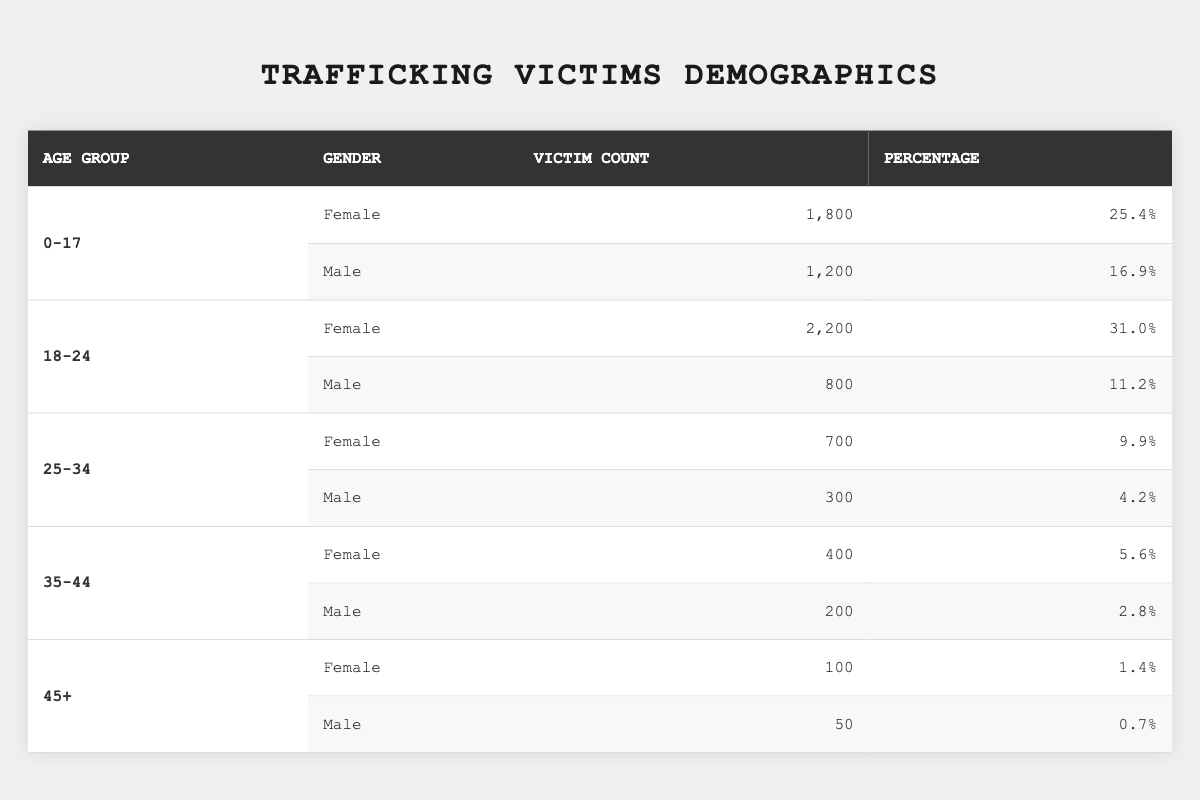What is the total number of trafficking victims aged 0-17? From the table, the number of female victims aged 0-17 is 1,800 and the number of male victims is 1,200. Adding these together gives 1,800 + 1,200 = 3,000.
Answer: 3,000 What percentage of trafficking victims are male in the age group 18-24? According to the table, the number of male victims aged 18-24 is 800. The total number of victims aged 18-24 (both genders) is 2,200 (female) + 800 (male) = 3,000. The percentage of male victims is therefore (800 / 3,000) * 100 = 26.67%.
Answer: 26.67% How many total female victims are there across all age groups? The table shows that the female victims in each age group are: 1,800 (0-17) + 2,200 (18-24) + 700 (25-34) + 400 (35-44) + 100 (45+) = 5,200.
Answer: 5,200 Is it true that there are more male victims in the 0-17 age group than in the 35-44 age group? The table lists 1,200 male victims in the 0-17 age group and 200 in the 35-44 age group. Since 1,200 is greater than 200, this statement is true.
Answer: Yes Which age group has the highest percentage of female victims? Reviewing the percentages, the 18-24 age group has the highest percentage of female victims at 31.0%.
Answer: 18-24 What is the ratio of female to male victims in the age group 25-34? The table shows 700 female victims and 300 male victims in the 25-34 age group. The ratio is 700:300, which simplifies to 7:3.
Answer: 7:3 How many victims are there in the 45+ age group compared to the total number of victims? The 45+ age group has 100 female and 50 male victims, totaling 150. The overall number of victims across all age groups can be calculated as 1,800 + 1,200 + 2,200 + 800 + 700 + 300 + 400 + 200 + 100 + 50 = 8,800. The comparison shows that the 45+ age group represents (150 / 8,800) * 100 = 1.7% of total victims.
Answer: 150 Which gender has the larger number of victims in the age group 35-44? The table lists 400 female victims and 200 male victims aged 35-44. Hence, there are more female victims.
Answer: Female How does the percentage of male victims in the 0-17 age group compare with that of the 25-34 age group? In the 0-17 age group, male victims constitute 16.9% (1,200 victims), and in the 25-34 age group, they are 4.2% (300 victims). Comparing these, 16.9% is greater than 4.2%.
Answer: 0-17 age group has a higher percentage 